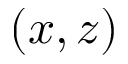Convert formula to latex. <formula><loc_0><loc_0><loc_500><loc_500>( x , z )</formula> 